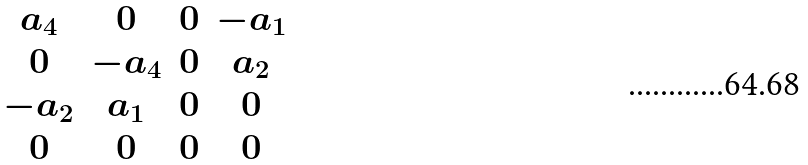Convert formula to latex. <formula><loc_0><loc_0><loc_500><loc_500>\begin{matrix} a _ { 4 } & 0 & 0 & - a _ { 1 } \\ 0 & - a _ { 4 } & 0 & a _ { 2 } \\ - a _ { 2 } & a _ { 1 } & 0 & 0 \\ 0 & 0 & 0 & 0 \end{matrix}</formula> 